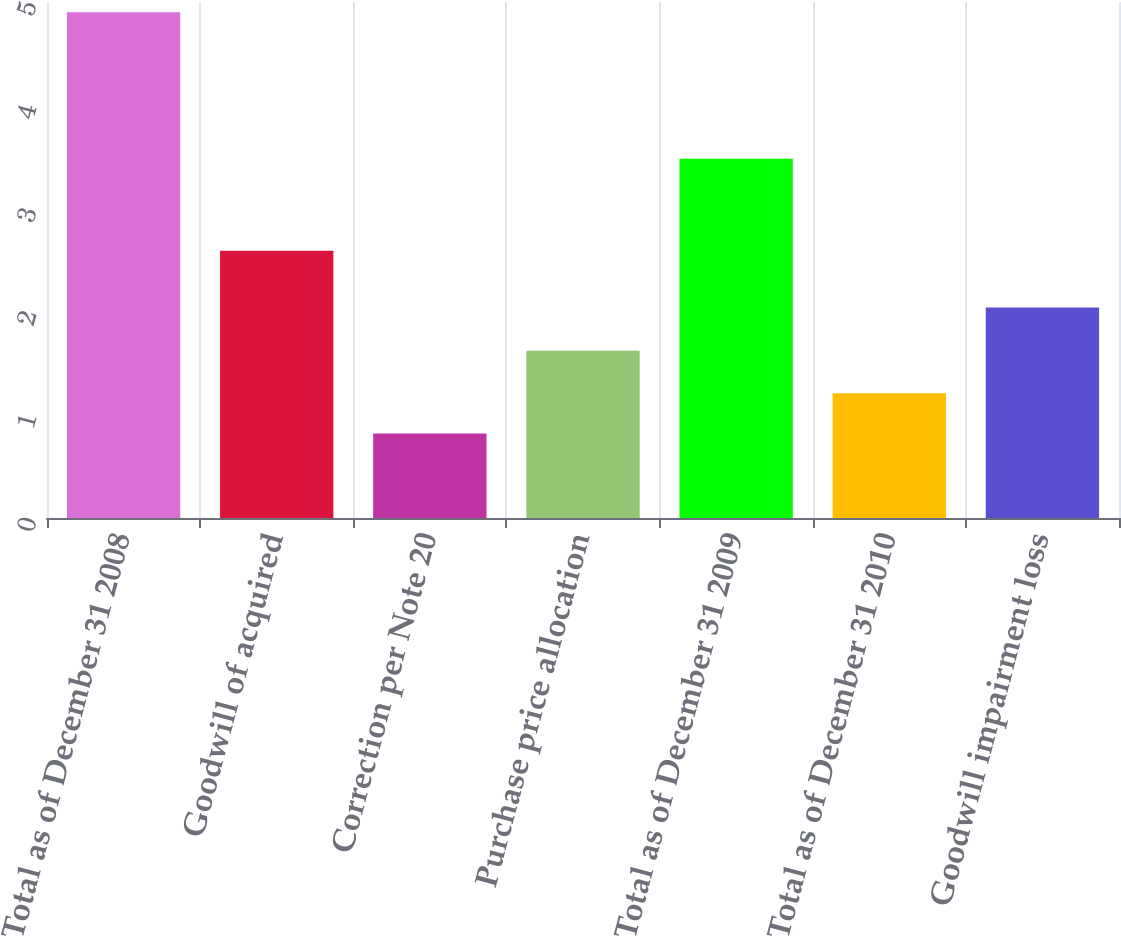Convert chart to OTSL. <chart><loc_0><loc_0><loc_500><loc_500><bar_chart><fcel>Total as of December 31 2008<fcel>Goodwill of acquired<fcel>Correction per Note 20<fcel>Purchase price allocation<fcel>Total as of December 31 2009<fcel>Total as of December 31 2010<fcel>Goodwill impairment loss<nl><fcel>4.9<fcel>2.59<fcel>0.82<fcel>1.62<fcel>3.48<fcel>1.21<fcel>2.04<nl></chart> 